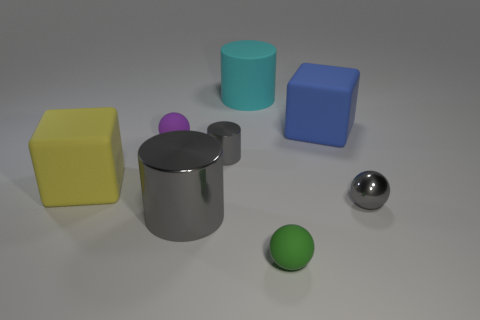Subtract all purple cubes. How many gray cylinders are left? 2 Subtract all gray metal cylinders. How many cylinders are left? 1 Add 1 tiny gray metallic cylinders. How many objects exist? 9 Subtract all blocks. How many objects are left? 6 Add 4 big cyan metallic cylinders. How many big cyan metallic cylinders exist? 4 Subtract 1 blue blocks. How many objects are left? 7 Subtract all cyan rubber objects. Subtract all large cyan rubber blocks. How many objects are left? 7 Add 4 gray metal cylinders. How many gray metal cylinders are left? 6 